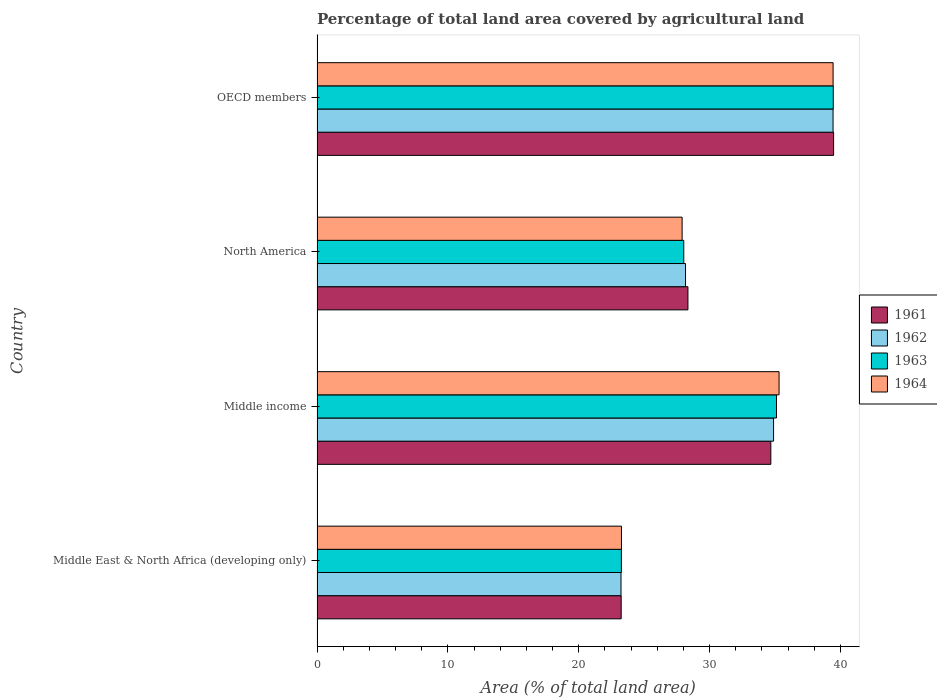How many groups of bars are there?
Ensure brevity in your answer.  4. Are the number of bars on each tick of the Y-axis equal?
Offer a very short reply. Yes. How many bars are there on the 3rd tick from the top?
Ensure brevity in your answer.  4. What is the label of the 3rd group of bars from the top?
Give a very brief answer. Middle income. In how many cases, is the number of bars for a given country not equal to the number of legend labels?
Your answer should be compact. 0. What is the percentage of agricultural land in 1962 in Middle East & North Africa (developing only)?
Offer a terse response. 23.23. Across all countries, what is the maximum percentage of agricultural land in 1964?
Provide a short and direct response. 39.44. Across all countries, what is the minimum percentage of agricultural land in 1962?
Provide a short and direct response. 23.23. In which country was the percentage of agricultural land in 1961 minimum?
Give a very brief answer. Middle East & North Africa (developing only). What is the total percentage of agricultural land in 1962 in the graph?
Give a very brief answer. 125.7. What is the difference between the percentage of agricultural land in 1962 in Middle East & North Africa (developing only) and that in North America?
Ensure brevity in your answer.  -4.93. What is the difference between the percentage of agricultural land in 1961 in North America and the percentage of agricultural land in 1964 in Middle East & North Africa (developing only)?
Make the answer very short. 5.08. What is the average percentage of agricultural land in 1963 per country?
Make the answer very short. 31.46. What is the difference between the percentage of agricultural land in 1961 and percentage of agricultural land in 1963 in Middle income?
Provide a short and direct response. -0.43. What is the ratio of the percentage of agricultural land in 1961 in North America to that in OECD members?
Keep it short and to the point. 0.72. Is the percentage of agricultural land in 1963 in Middle East & North Africa (developing only) less than that in North America?
Your response must be concise. Yes. Is the difference between the percentage of agricultural land in 1961 in Middle income and North America greater than the difference between the percentage of agricultural land in 1963 in Middle income and North America?
Give a very brief answer. No. What is the difference between the highest and the second highest percentage of agricultural land in 1963?
Provide a succinct answer. 4.34. What is the difference between the highest and the lowest percentage of agricultural land in 1962?
Offer a very short reply. 16.2. In how many countries, is the percentage of agricultural land in 1964 greater than the average percentage of agricultural land in 1964 taken over all countries?
Your response must be concise. 2. What does the 2nd bar from the bottom in Middle East & North Africa (developing only) represents?
Provide a short and direct response. 1962. Is it the case that in every country, the sum of the percentage of agricultural land in 1961 and percentage of agricultural land in 1963 is greater than the percentage of agricultural land in 1964?
Your answer should be compact. Yes. What is the difference between two consecutive major ticks on the X-axis?
Give a very brief answer. 10. Are the values on the major ticks of X-axis written in scientific E-notation?
Your answer should be compact. No. Does the graph contain any zero values?
Your answer should be very brief. No. How many legend labels are there?
Ensure brevity in your answer.  4. How are the legend labels stacked?
Provide a succinct answer. Vertical. What is the title of the graph?
Make the answer very short. Percentage of total land area covered by agricultural land. What is the label or title of the X-axis?
Give a very brief answer. Area (% of total land area). What is the Area (% of total land area) of 1961 in Middle East & North Africa (developing only)?
Offer a very short reply. 23.24. What is the Area (% of total land area) of 1962 in Middle East & North Africa (developing only)?
Your answer should be compact. 23.23. What is the Area (% of total land area) of 1963 in Middle East & North Africa (developing only)?
Provide a succinct answer. 23.26. What is the Area (% of total land area) in 1964 in Middle East & North Africa (developing only)?
Provide a short and direct response. 23.26. What is the Area (% of total land area) in 1961 in Middle income?
Make the answer very short. 34.68. What is the Area (% of total land area) of 1962 in Middle income?
Your response must be concise. 34.89. What is the Area (% of total land area) in 1963 in Middle income?
Keep it short and to the point. 35.11. What is the Area (% of total land area) of 1964 in Middle income?
Your answer should be compact. 35.31. What is the Area (% of total land area) in 1961 in North America?
Your response must be concise. 28.34. What is the Area (% of total land area) of 1962 in North America?
Your answer should be compact. 28.16. What is the Area (% of total land area) of 1963 in North America?
Provide a short and direct response. 28.02. What is the Area (% of total land area) in 1964 in North America?
Your answer should be very brief. 27.9. What is the Area (% of total land area) of 1961 in OECD members?
Offer a terse response. 39.47. What is the Area (% of total land area) in 1962 in OECD members?
Your answer should be very brief. 39.43. What is the Area (% of total land area) of 1963 in OECD members?
Provide a short and direct response. 39.45. What is the Area (% of total land area) of 1964 in OECD members?
Ensure brevity in your answer.  39.44. Across all countries, what is the maximum Area (% of total land area) of 1961?
Your answer should be very brief. 39.47. Across all countries, what is the maximum Area (% of total land area) in 1962?
Give a very brief answer. 39.43. Across all countries, what is the maximum Area (% of total land area) in 1963?
Your answer should be very brief. 39.45. Across all countries, what is the maximum Area (% of total land area) of 1964?
Your answer should be compact. 39.44. Across all countries, what is the minimum Area (% of total land area) in 1961?
Make the answer very short. 23.24. Across all countries, what is the minimum Area (% of total land area) of 1962?
Offer a very short reply. 23.23. Across all countries, what is the minimum Area (% of total land area) in 1963?
Offer a very short reply. 23.26. Across all countries, what is the minimum Area (% of total land area) in 1964?
Provide a succinct answer. 23.26. What is the total Area (% of total land area) in 1961 in the graph?
Your response must be concise. 125.74. What is the total Area (% of total land area) in 1962 in the graph?
Offer a very short reply. 125.7. What is the total Area (% of total land area) of 1963 in the graph?
Your response must be concise. 125.84. What is the total Area (% of total land area) in 1964 in the graph?
Offer a very short reply. 125.9. What is the difference between the Area (% of total land area) in 1961 in Middle East & North Africa (developing only) and that in Middle income?
Provide a short and direct response. -11.44. What is the difference between the Area (% of total land area) in 1962 in Middle East & North Africa (developing only) and that in Middle income?
Ensure brevity in your answer.  -11.66. What is the difference between the Area (% of total land area) of 1963 in Middle East & North Africa (developing only) and that in Middle income?
Your answer should be compact. -11.85. What is the difference between the Area (% of total land area) of 1964 in Middle East & North Africa (developing only) and that in Middle income?
Give a very brief answer. -12.04. What is the difference between the Area (% of total land area) of 1961 in Middle East & North Africa (developing only) and that in North America?
Your answer should be very brief. -5.1. What is the difference between the Area (% of total land area) of 1962 in Middle East & North Africa (developing only) and that in North America?
Your response must be concise. -4.93. What is the difference between the Area (% of total land area) of 1963 in Middle East & North Africa (developing only) and that in North America?
Make the answer very short. -4.77. What is the difference between the Area (% of total land area) of 1964 in Middle East & North Africa (developing only) and that in North America?
Make the answer very short. -4.64. What is the difference between the Area (% of total land area) of 1961 in Middle East & North Africa (developing only) and that in OECD members?
Your answer should be compact. -16.23. What is the difference between the Area (% of total land area) in 1962 in Middle East & North Africa (developing only) and that in OECD members?
Give a very brief answer. -16.2. What is the difference between the Area (% of total land area) of 1963 in Middle East & North Africa (developing only) and that in OECD members?
Keep it short and to the point. -16.19. What is the difference between the Area (% of total land area) in 1964 in Middle East & North Africa (developing only) and that in OECD members?
Make the answer very short. -16.17. What is the difference between the Area (% of total land area) in 1961 in Middle income and that in North America?
Provide a short and direct response. 6.33. What is the difference between the Area (% of total land area) of 1962 in Middle income and that in North America?
Give a very brief answer. 6.73. What is the difference between the Area (% of total land area) in 1963 in Middle income and that in North America?
Offer a terse response. 7.08. What is the difference between the Area (% of total land area) of 1964 in Middle income and that in North America?
Make the answer very short. 7.41. What is the difference between the Area (% of total land area) in 1961 in Middle income and that in OECD members?
Your answer should be very brief. -4.8. What is the difference between the Area (% of total land area) in 1962 in Middle income and that in OECD members?
Offer a very short reply. -4.55. What is the difference between the Area (% of total land area) of 1963 in Middle income and that in OECD members?
Offer a very short reply. -4.34. What is the difference between the Area (% of total land area) of 1964 in Middle income and that in OECD members?
Your response must be concise. -4.13. What is the difference between the Area (% of total land area) in 1961 in North America and that in OECD members?
Make the answer very short. -11.13. What is the difference between the Area (% of total land area) of 1962 in North America and that in OECD members?
Your answer should be compact. -11.28. What is the difference between the Area (% of total land area) of 1963 in North America and that in OECD members?
Provide a short and direct response. -11.42. What is the difference between the Area (% of total land area) in 1964 in North America and that in OECD members?
Offer a very short reply. -11.54. What is the difference between the Area (% of total land area) of 1961 in Middle East & North Africa (developing only) and the Area (% of total land area) of 1962 in Middle income?
Offer a very short reply. -11.65. What is the difference between the Area (% of total land area) of 1961 in Middle East & North Africa (developing only) and the Area (% of total land area) of 1963 in Middle income?
Make the answer very short. -11.87. What is the difference between the Area (% of total land area) in 1961 in Middle East & North Africa (developing only) and the Area (% of total land area) in 1964 in Middle income?
Your answer should be very brief. -12.06. What is the difference between the Area (% of total land area) in 1962 in Middle East & North Africa (developing only) and the Area (% of total land area) in 1963 in Middle income?
Give a very brief answer. -11.88. What is the difference between the Area (% of total land area) of 1962 in Middle East & North Africa (developing only) and the Area (% of total land area) of 1964 in Middle income?
Give a very brief answer. -12.08. What is the difference between the Area (% of total land area) in 1963 in Middle East & North Africa (developing only) and the Area (% of total land area) in 1964 in Middle income?
Your answer should be compact. -12.05. What is the difference between the Area (% of total land area) of 1961 in Middle East & North Africa (developing only) and the Area (% of total land area) of 1962 in North America?
Your answer should be very brief. -4.92. What is the difference between the Area (% of total land area) of 1961 in Middle East & North Africa (developing only) and the Area (% of total land area) of 1963 in North America?
Ensure brevity in your answer.  -4.78. What is the difference between the Area (% of total land area) of 1961 in Middle East & North Africa (developing only) and the Area (% of total land area) of 1964 in North America?
Your response must be concise. -4.66. What is the difference between the Area (% of total land area) in 1962 in Middle East & North Africa (developing only) and the Area (% of total land area) in 1963 in North America?
Offer a very short reply. -4.8. What is the difference between the Area (% of total land area) of 1962 in Middle East & North Africa (developing only) and the Area (% of total land area) of 1964 in North America?
Your answer should be very brief. -4.67. What is the difference between the Area (% of total land area) of 1963 in Middle East & North Africa (developing only) and the Area (% of total land area) of 1964 in North America?
Give a very brief answer. -4.64. What is the difference between the Area (% of total land area) in 1961 in Middle East & North Africa (developing only) and the Area (% of total land area) in 1962 in OECD members?
Ensure brevity in your answer.  -16.19. What is the difference between the Area (% of total land area) of 1961 in Middle East & North Africa (developing only) and the Area (% of total land area) of 1963 in OECD members?
Offer a terse response. -16.21. What is the difference between the Area (% of total land area) of 1961 in Middle East & North Africa (developing only) and the Area (% of total land area) of 1964 in OECD members?
Offer a terse response. -16.19. What is the difference between the Area (% of total land area) in 1962 in Middle East & North Africa (developing only) and the Area (% of total land area) in 1963 in OECD members?
Your answer should be very brief. -16.22. What is the difference between the Area (% of total land area) of 1962 in Middle East & North Africa (developing only) and the Area (% of total land area) of 1964 in OECD members?
Your answer should be compact. -16.21. What is the difference between the Area (% of total land area) of 1963 in Middle East & North Africa (developing only) and the Area (% of total land area) of 1964 in OECD members?
Offer a terse response. -16.18. What is the difference between the Area (% of total land area) of 1961 in Middle income and the Area (% of total land area) of 1962 in North America?
Ensure brevity in your answer.  6.52. What is the difference between the Area (% of total land area) in 1961 in Middle income and the Area (% of total land area) in 1963 in North America?
Offer a terse response. 6.65. What is the difference between the Area (% of total land area) of 1961 in Middle income and the Area (% of total land area) of 1964 in North America?
Offer a very short reply. 6.78. What is the difference between the Area (% of total land area) in 1962 in Middle income and the Area (% of total land area) in 1963 in North America?
Make the answer very short. 6.86. What is the difference between the Area (% of total land area) in 1962 in Middle income and the Area (% of total land area) in 1964 in North America?
Ensure brevity in your answer.  6.99. What is the difference between the Area (% of total land area) of 1963 in Middle income and the Area (% of total land area) of 1964 in North America?
Provide a succinct answer. 7.21. What is the difference between the Area (% of total land area) in 1961 in Middle income and the Area (% of total land area) in 1962 in OECD members?
Ensure brevity in your answer.  -4.76. What is the difference between the Area (% of total land area) in 1961 in Middle income and the Area (% of total land area) in 1963 in OECD members?
Offer a very short reply. -4.77. What is the difference between the Area (% of total land area) of 1961 in Middle income and the Area (% of total land area) of 1964 in OECD members?
Keep it short and to the point. -4.76. What is the difference between the Area (% of total land area) of 1962 in Middle income and the Area (% of total land area) of 1963 in OECD members?
Your answer should be very brief. -4.56. What is the difference between the Area (% of total land area) in 1962 in Middle income and the Area (% of total land area) in 1964 in OECD members?
Make the answer very short. -4.55. What is the difference between the Area (% of total land area) in 1963 in Middle income and the Area (% of total land area) in 1964 in OECD members?
Ensure brevity in your answer.  -4.33. What is the difference between the Area (% of total land area) of 1961 in North America and the Area (% of total land area) of 1962 in OECD members?
Offer a terse response. -11.09. What is the difference between the Area (% of total land area) in 1961 in North America and the Area (% of total land area) in 1963 in OECD members?
Your answer should be very brief. -11.11. What is the difference between the Area (% of total land area) in 1961 in North America and the Area (% of total land area) in 1964 in OECD members?
Offer a terse response. -11.09. What is the difference between the Area (% of total land area) of 1962 in North America and the Area (% of total land area) of 1963 in OECD members?
Make the answer very short. -11.29. What is the difference between the Area (% of total land area) of 1962 in North America and the Area (% of total land area) of 1964 in OECD members?
Your response must be concise. -11.28. What is the difference between the Area (% of total land area) in 1963 in North America and the Area (% of total land area) in 1964 in OECD members?
Provide a succinct answer. -11.41. What is the average Area (% of total land area) in 1961 per country?
Your answer should be compact. 31.43. What is the average Area (% of total land area) of 1962 per country?
Keep it short and to the point. 31.43. What is the average Area (% of total land area) of 1963 per country?
Ensure brevity in your answer.  31.46. What is the average Area (% of total land area) of 1964 per country?
Give a very brief answer. 31.48. What is the difference between the Area (% of total land area) in 1961 and Area (% of total land area) in 1962 in Middle East & North Africa (developing only)?
Your answer should be compact. 0.01. What is the difference between the Area (% of total land area) in 1961 and Area (% of total land area) in 1963 in Middle East & North Africa (developing only)?
Give a very brief answer. -0.02. What is the difference between the Area (% of total land area) in 1961 and Area (% of total land area) in 1964 in Middle East & North Africa (developing only)?
Offer a terse response. -0.02. What is the difference between the Area (% of total land area) of 1962 and Area (% of total land area) of 1963 in Middle East & North Africa (developing only)?
Provide a short and direct response. -0.03. What is the difference between the Area (% of total land area) in 1962 and Area (% of total land area) in 1964 in Middle East & North Africa (developing only)?
Offer a very short reply. -0.03. What is the difference between the Area (% of total land area) in 1963 and Area (% of total land area) in 1964 in Middle East & North Africa (developing only)?
Your answer should be compact. -0.01. What is the difference between the Area (% of total land area) of 1961 and Area (% of total land area) of 1962 in Middle income?
Provide a succinct answer. -0.21. What is the difference between the Area (% of total land area) of 1961 and Area (% of total land area) of 1963 in Middle income?
Provide a short and direct response. -0.43. What is the difference between the Area (% of total land area) of 1961 and Area (% of total land area) of 1964 in Middle income?
Offer a very short reply. -0.63. What is the difference between the Area (% of total land area) in 1962 and Area (% of total land area) in 1963 in Middle income?
Make the answer very short. -0.22. What is the difference between the Area (% of total land area) of 1962 and Area (% of total land area) of 1964 in Middle income?
Ensure brevity in your answer.  -0.42. What is the difference between the Area (% of total land area) in 1963 and Area (% of total land area) in 1964 in Middle income?
Your response must be concise. -0.2. What is the difference between the Area (% of total land area) in 1961 and Area (% of total land area) in 1962 in North America?
Offer a terse response. 0.19. What is the difference between the Area (% of total land area) of 1961 and Area (% of total land area) of 1963 in North America?
Your answer should be very brief. 0.32. What is the difference between the Area (% of total land area) of 1961 and Area (% of total land area) of 1964 in North America?
Provide a short and direct response. 0.44. What is the difference between the Area (% of total land area) of 1962 and Area (% of total land area) of 1963 in North America?
Offer a terse response. 0.13. What is the difference between the Area (% of total land area) of 1962 and Area (% of total land area) of 1964 in North America?
Offer a terse response. 0.26. What is the difference between the Area (% of total land area) of 1963 and Area (% of total land area) of 1964 in North America?
Provide a succinct answer. 0.13. What is the difference between the Area (% of total land area) of 1961 and Area (% of total land area) of 1962 in OECD members?
Your response must be concise. 0.04. What is the difference between the Area (% of total land area) of 1961 and Area (% of total land area) of 1963 in OECD members?
Give a very brief answer. 0.03. What is the difference between the Area (% of total land area) in 1961 and Area (% of total land area) in 1964 in OECD members?
Keep it short and to the point. 0.04. What is the difference between the Area (% of total land area) of 1962 and Area (% of total land area) of 1963 in OECD members?
Provide a short and direct response. -0.02. What is the difference between the Area (% of total land area) of 1962 and Area (% of total land area) of 1964 in OECD members?
Make the answer very short. -0. What is the difference between the Area (% of total land area) in 1963 and Area (% of total land area) in 1964 in OECD members?
Your answer should be compact. 0.01. What is the ratio of the Area (% of total land area) in 1961 in Middle East & North Africa (developing only) to that in Middle income?
Keep it short and to the point. 0.67. What is the ratio of the Area (% of total land area) in 1962 in Middle East & North Africa (developing only) to that in Middle income?
Provide a succinct answer. 0.67. What is the ratio of the Area (% of total land area) in 1963 in Middle East & North Africa (developing only) to that in Middle income?
Your answer should be very brief. 0.66. What is the ratio of the Area (% of total land area) of 1964 in Middle East & North Africa (developing only) to that in Middle income?
Your answer should be compact. 0.66. What is the ratio of the Area (% of total land area) of 1961 in Middle East & North Africa (developing only) to that in North America?
Offer a very short reply. 0.82. What is the ratio of the Area (% of total land area) of 1962 in Middle East & North Africa (developing only) to that in North America?
Give a very brief answer. 0.82. What is the ratio of the Area (% of total land area) in 1963 in Middle East & North Africa (developing only) to that in North America?
Ensure brevity in your answer.  0.83. What is the ratio of the Area (% of total land area) in 1964 in Middle East & North Africa (developing only) to that in North America?
Give a very brief answer. 0.83. What is the ratio of the Area (% of total land area) of 1961 in Middle East & North Africa (developing only) to that in OECD members?
Provide a short and direct response. 0.59. What is the ratio of the Area (% of total land area) in 1962 in Middle East & North Africa (developing only) to that in OECD members?
Your response must be concise. 0.59. What is the ratio of the Area (% of total land area) in 1963 in Middle East & North Africa (developing only) to that in OECD members?
Make the answer very short. 0.59. What is the ratio of the Area (% of total land area) in 1964 in Middle East & North Africa (developing only) to that in OECD members?
Give a very brief answer. 0.59. What is the ratio of the Area (% of total land area) of 1961 in Middle income to that in North America?
Your answer should be very brief. 1.22. What is the ratio of the Area (% of total land area) in 1962 in Middle income to that in North America?
Your answer should be compact. 1.24. What is the ratio of the Area (% of total land area) of 1963 in Middle income to that in North America?
Your answer should be compact. 1.25. What is the ratio of the Area (% of total land area) of 1964 in Middle income to that in North America?
Provide a succinct answer. 1.27. What is the ratio of the Area (% of total land area) of 1961 in Middle income to that in OECD members?
Provide a short and direct response. 0.88. What is the ratio of the Area (% of total land area) of 1962 in Middle income to that in OECD members?
Your response must be concise. 0.88. What is the ratio of the Area (% of total land area) in 1963 in Middle income to that in OECD members?
Your answer should be compact. 0.89. What is the ratio of the Area (% of total land area) in 1964 in Middle income to that in OECD members?
Your answer should be very brief. 0.9. What is the ratio of the Area (% of total land area) of 1961 in North America to that in OECD members?
Offer a very short reply. 0.72. What is the ratio of the Area (% of total land area) of 1962 in North America to that in OECD members?
Offer a terse response. 0.71. What is the ratio of the Area (% of total land area) of 1963 in North America to that in OECD members?
Your response must be concise. 0.71. What is the ratio of the Area (% of total land area) in 1964 in North America to that in OECD members?
Keep it short and to the point. 0.71. What is the difference between the highest and the second highest Area (% of total land area) of 1961?
Ensure brevity in your answer.  4.8. What is the difference between the highest and the second highest Area (% of total land area) of 1962?
Offer a terse response. 4.55. What is the difference between the highest and the second highest Area (% of total land area) of 1963?
Your answer should be compact. 4.34. What is the difference between the highest and the second highest Area (% of total land area) in 1964?
Your answer should be compact. 4.13. What is the difference between the highest and the lowest Area (% of total land area) in 1961?
Offer a very short reply. 16.23. What is the difference between the highest and the lowest Area (% of total land area) of 1962?
Ensure brevity in your answer.  16.2. What is the difference between the highest and the lowest Area (% of total land area) of 1963?
Provide a short and direct response. 16.19. What is the difference between the highest and the lowest Area (% of total land area) in 1964?
Ensure brevity in your answer.  16.17. 